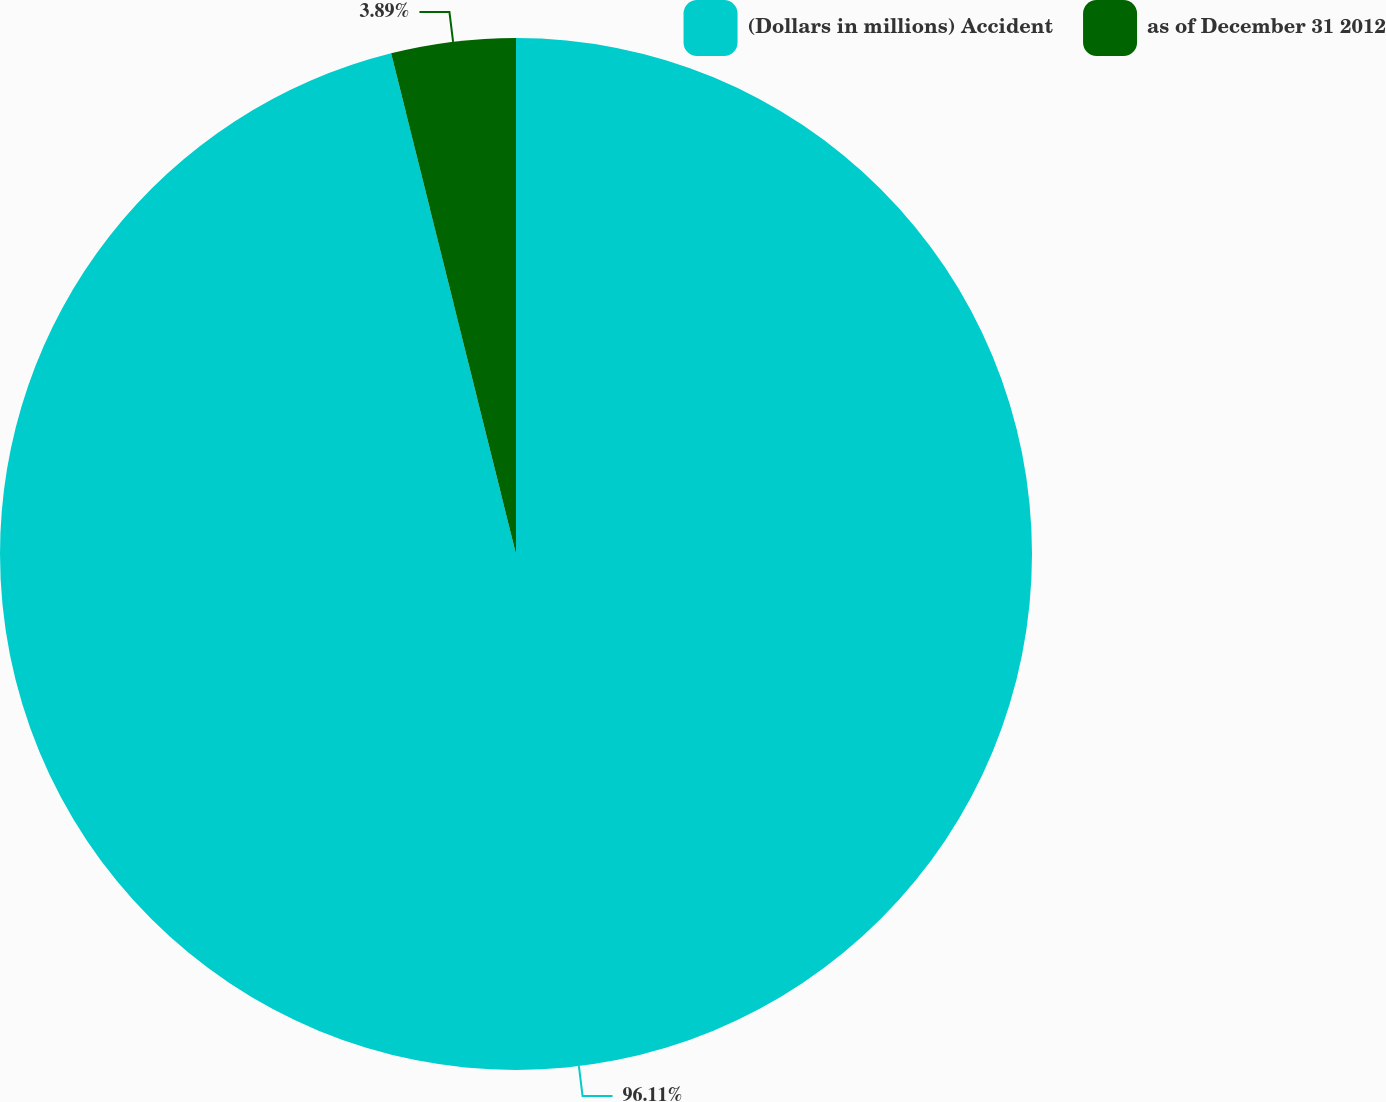<chart> <loc_0><loc_0><loc_500><loc_500><pie_chart><fcel>(Dollars in millions) Accident<fcel>as of December 31 2012<nl><fcel>96.11%<fcel>3.89%<nl></chart> 